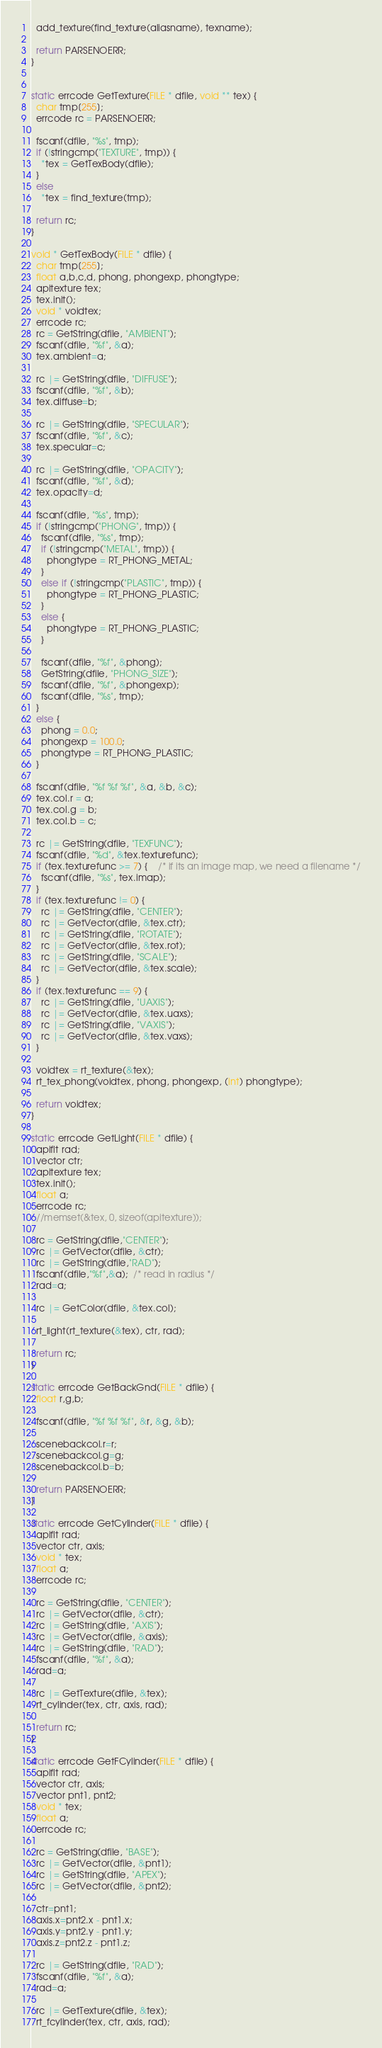Convert code to text. <code><loc_0><loc_0><loc_500><loc_500><_C++_>  add_texture(find_texture(aliasname), texname); 

  return PARSENOERR;
}


static errcode GetTexture(FILE * dfile, void ** tex) {
  char tmp[255];
  errcode rc = PARSENOERR;

  fscanf(dfile, "%s", tmp);
  if (!stringcmp("TEXTURE", tmp)) {	
    *tex = GetTexBody(dfile);
  }
  else
    *tex = find_texture(tmp);

  return rc;
}

void * GetTexBody(FILE * dfile) {
  char tmp[255];
  float a,b,c,d, phong, phongexp, phongtype;
  apitexture tex;
  tex.init();
  void * voidtex; 
  errcode rc;
  rc = GetString(dfile, "AMBIENT");
  fscanf(dfile, "%f", &a); 
  tex.ambient=a;

  rc |= GetString(dfile, "DIFFUSE");
  fscanf(dfile, "%f", &b);
  tex.diffuse=b;

  rc |= GetString(dfile, "SPECULAR");
  fscanf(dfile, "%f", &c);
  tex.specular=c;

  rc |= GetString(dfile, "OPACITY");
  fscanf(dfile, "%f", &d);  
  tex.opacity=d;

  fscanf(dfile, "%s", tmp);
  if (!stringcmp("PHONG", tmp)) {
    fscanf(dfile, "%s", tmp);
    if (!stringcmp("METAL", tmp)) {
      phongtype = RT_PHONG_METAL;
    }
    else if (!stringcmp("PLASTIC", tmp)) {
      phongtype = RT_PHONG_PLASTIC;
    }
    else {
      phongtype = RT_PHONG_PLASTIC;
    } 

    fscanf(dfile, "%f", &phong);
    GetString(dfile, "PHONG_SIZE");
    fscanf(dfile, "%f", &phongexp);
    fscanf(dfile, "%s", tmp);
  }     
  else { 
    phong = 0.0;
    phongexp = 100.0;
    phongtype = RT_PHONG_PLASTIC;
  }
  
  fscanf(dfile, "%f %f %f", &a, &b, &c);
  tex.col.r = a;
  tex.col.g = b;
  tex.col.b = c;
 
  rc |= GetString(dfile, "TEXFUNC");
  fscanf(dfile, "%d", &tex.texturefunc);
  if (tex.texturefunc >= 7) {    /* if its an image map, we need a filename */
    fscanf(dfile, "%s", tex.imap);
  }
  if (tex.texturefunc != 0) {
    rc |= GetString(dfile, "CENTER");
    rc |= GetVector(dfile, &tex.ctr);
    rc |= GetString(dfile, "ROTATE");
    rc |= GetVector(dfile, &tex.rot);
    rc |= GetString(dfile, "SCALE");
    rc |= GetVector(dfile, &tex.scale);
  }
  if (tex.texturefunc == 9) {
    rc |= GetString(dfile, "UAXIS");
    rc |= GetVector(dfile, &tex.uaxs);
    rc |= GetString(dfile, "VAXIS");
    rc |= GetVector(dfile, &tex.vaxs);
  }

  voidtex = rt_texture(&tex);
  rt_tex_phong(voidtex, phong, phongexp, (int) phongtype);

  return voidtex;
}

static errcode GetLight(FILE * dfile) {
  apiflt rad;
  vector ctr;
  apitexture tex;
  tex.init();
  float a; 
  errcode rc;
  //memset(&tex, 0, sizeof(apitexture)); 

  rc = GetString(dfile,"CENTER"); 
  rc |= GetVector(dfile, &ctr); 
  rc |= GetString(dfile,"RAD");
  fscanf(dfile,"%f",&a);  /* read in radius */ 
  rad=a;

  rc |= GetColor(dfile, &tex.col);
  
  rt_light(rt_texture(&tex), ctr, rad);

  return rc;
}

static errcode GetBackGnd(FILE * dfile) {
  float r,g,b;
  
  fscanf(dfile, "%f %f %f", &r, &g, &b);

  scenebackcol.r=r;
  scenebackcol.g=g;
  scenebackcol.b=b;

  return PARSENOERR;
}

static errcode GetCylinder(FILE * dfile) {
  apiflt rad;
  vector ctr, axis;
  void * tex;
  float a;
  errcode rc;

  rc = GetString(dfile, "CENTER");
  rc |= GetVector(dfile, &ctr);
  rc |= GetString(dfile, "AXIS");
  rc |= GetVector(dfile, &axis);
  rc |= GetString(dfile, "RAD");
  fscanf(dfile, "%f", &a);
  rad=a;

  rc |= GetTexture(dfile, &tex);
  rt_cylinder(tex, ctr, axis, rad); 

  return rc;
}

static errcode GetFCylinder(FILE * dfile) {
  apiflt rad;
  vector ctr, axis;
  vector pnt1, pnt2;
  void * tex;
  float a;
  errcode rc;

  rc = GetString(dfile, "BASE");
  rc |= GetVector(dfile, &pnt1);
  rc |= GetString(dfile, "APEX");
  rc |= GetVector(dfile, &pnt2);

  ctr=pnt1;
  axis.x=pnt2.x - pnt1.x; 
  axis.y=pnt2.y - pnt1.y;
  axis.z=pnt2.z - pnt1.z;

  rc |= GetString(dfile, "RAD");
  fscanf(dfile, "%f", &a);
  rad=a;

  rc |= GetTexture(dfile, &tex);
  rt_fcylinder(tex, ctr, axis, rad); 
</code> 